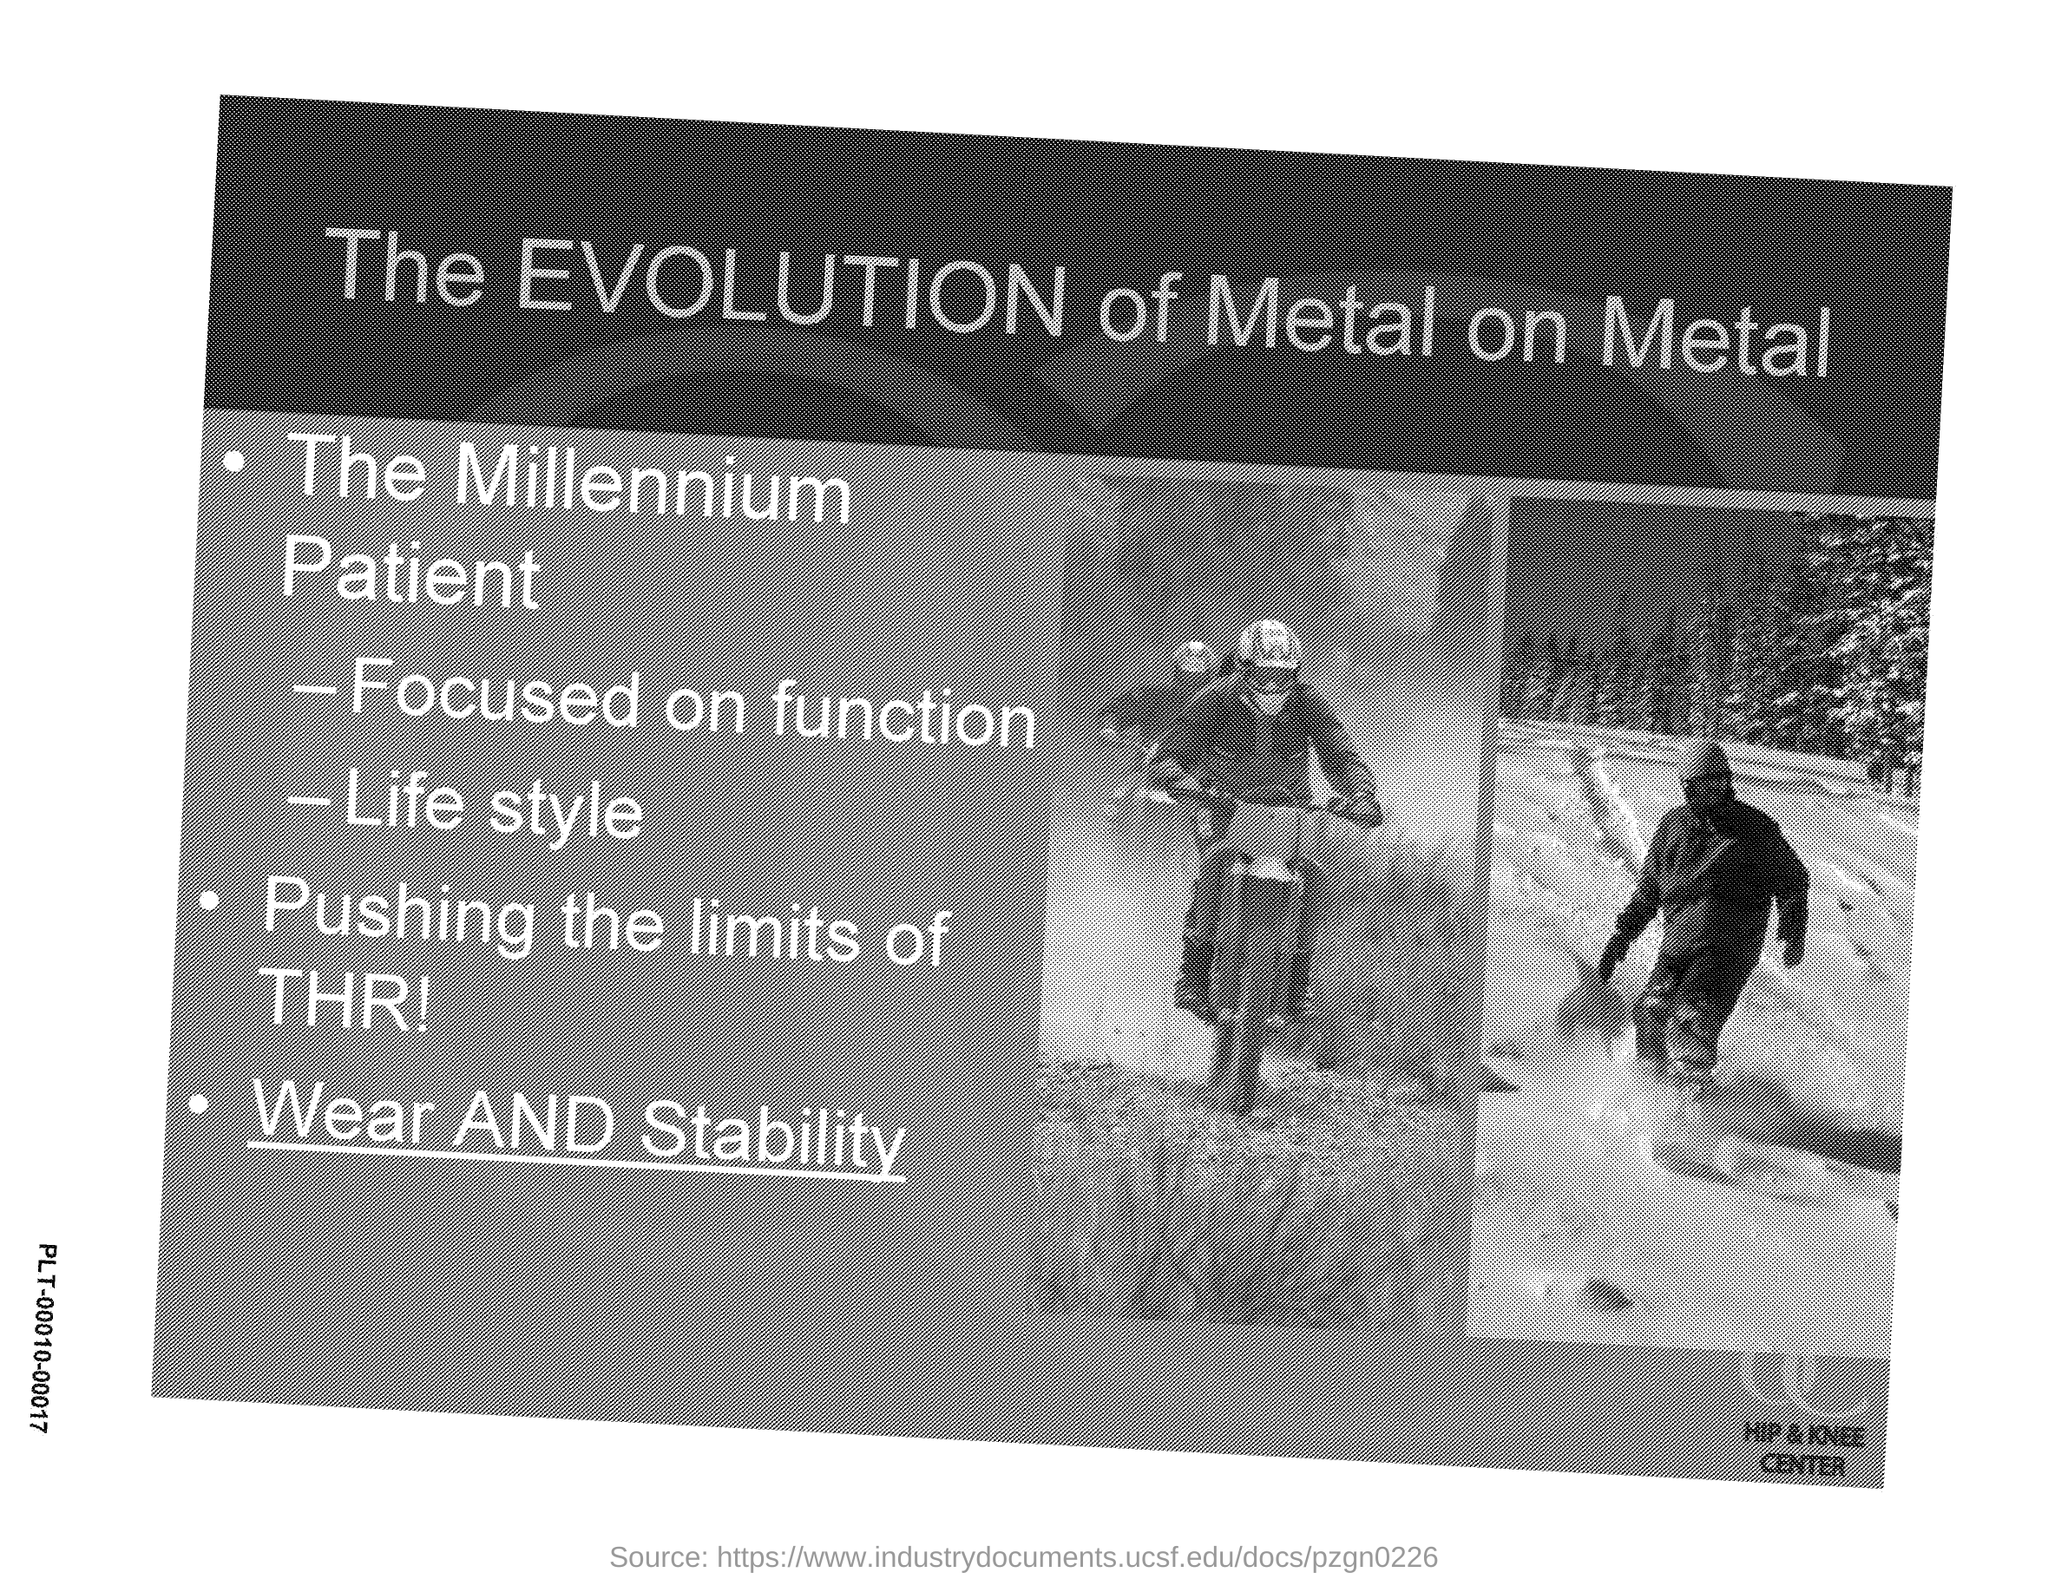What is the title given?
Give a very brief answer. The EVOLUTION of Metal on metal. 